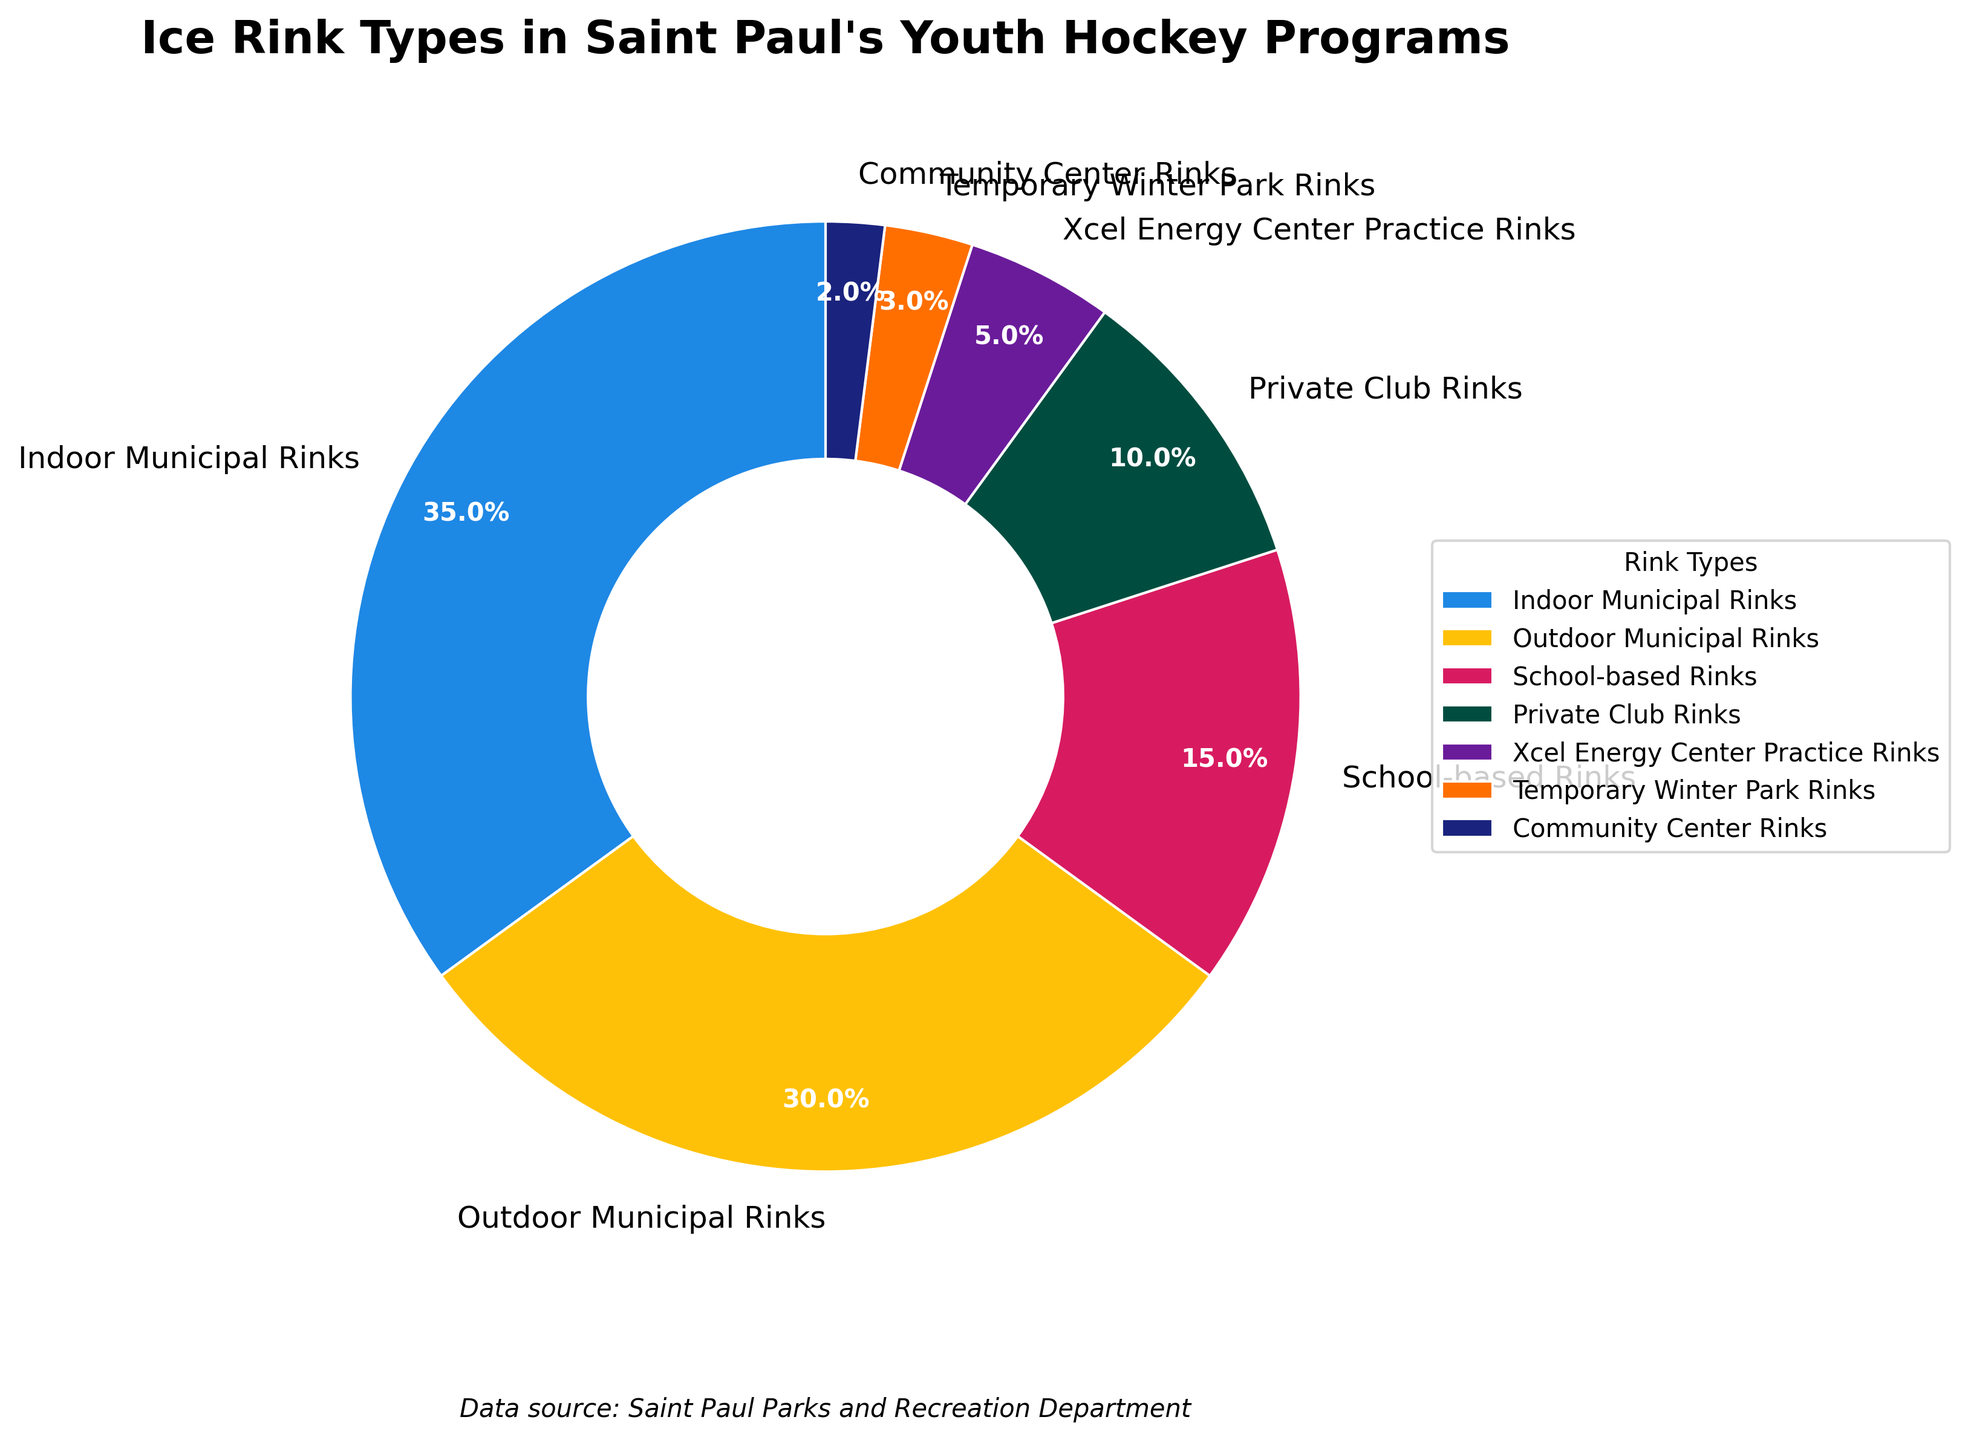Which ice rink type has the largest percentage in Saint Paul's youth hockey programs? The ice rink type with the largest percentage in the pie chart is the one with the largest slice. "Indoor Municipal Rinks" has the largest slice at 35%.
Answer: Indoor Municipal Rinks How much more popular are Indoor Municipal Rinks compared to Private Club Rinks? To find how much more popular Indoor Municipal Rinks are compared to Private Club Rinks, subtract the percentage of Private Club Rinks (10%) from Indoor Municipal Rinks (35%). 35% - 10% equals 25%.
Answer: 25% What's the combined percentage of outdoor and indoor municipal rinks? To find the combined percentage, add the percentage of Outdoor Municipal Rinks (30%) to Indoor Municipal Rinks (35%). 30% + 35% equals 65%.
Answer: 65% Which rink type has the smallest percentage, and what is its percentage? The rink type with the smallest percentage is the one with the smallest slice in the pie chart. "Community Center Rinks" has the smallest slice at 2%.
Answer: Community Center Rinks, 2% What is the difference in percentage between the highest and the lowest rink types? Subtract the percentage of the smallest slice (Community Center Rinks, 2%) from the largest slice (Indoor Municipal Rinks, 35%). 35% - 2% equals 33%.
Answer: 33% What is the visual color associated with School-based Rinks in the chart? Identify the color of the slice associated with "School-based Rinks" in the pie chart. School-based Rinks are shown in pink.
Answer: Pink Are the Temporary Winter Park Rinks used more or less than the School-based Rinks, and by what percentage? Compare the percentages of Temporary Winter Park Rinks (3%) and School-based Rinks (15%). Subtract the percentage of Temporary Winter Park Rinks from School-based Rinks. 15% - 3% equals 12%. School-based Rinks are used more by 12%.
Answer: More, 12% Which two rink types together constitute more than 60% of the total? Add the percentages of different rink types to find pairs that sum to more than 60%. Indoor Municipal Rinks (35%) + Outdoor Municipal Rinks (30%) equals 65%, which is more than 60%.
Answer: Indoor Municipal Rinks and Outdoor Municipal Rinks What are the percentages of non-municipal rink types combined? Add the percentages of rink types that are not municipal. School-based Rinks (15%) + Private Club Rinks (10%) + Xcel Energy Center Practice Rinks (5%) + Temporary Winter Park Rinks (3%) + Community Center Rinks (2%). The total is 35%.
Answer: 35% By what percentage are the Xcel Energy Center Practice Rinks less popular than Indoor Municipal Rinks? Subtract the percentage of Xcel Energy Center Practice Rinks (5%) from Indoor Municipal Rinks (35%). 35% - 5% equals 30%.
Answer: 30% 